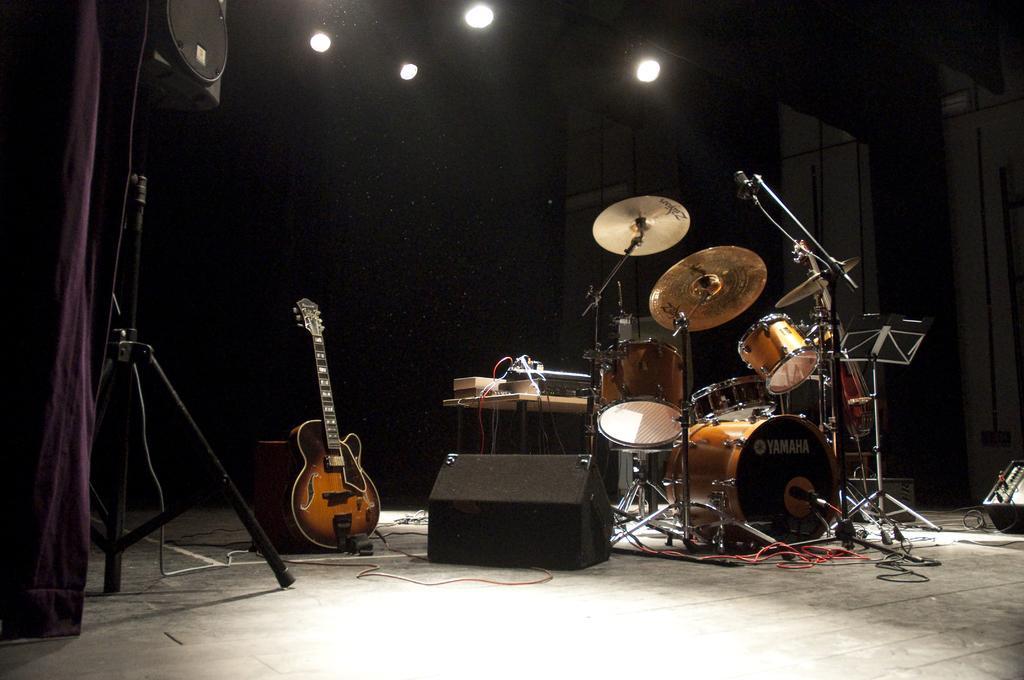In one or two sentences, can you explain what this image depicts? in this picture we can see a room with a musical instruments we can also a lights over the top of the room,where we can also see some cables. 